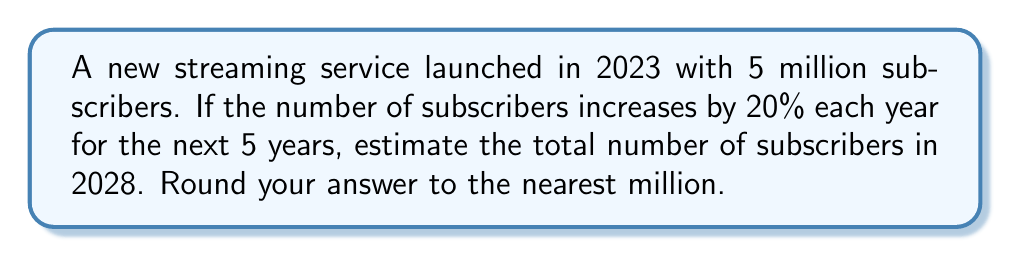What is the answer to this math problem? Let's approach this step-by-step:

1) The initial number of subscribers in 2023 is 5 million.

2) Each year, the number of subscribers increases by 20%. This means we multiply the previous year's number by 1.20 (100% + 20% = 120% = 1.20).

3) Let's calculate the number of subscribers for each year:

   2023 (initial): 5 million
   2024: $5 \times 1.20 = 6$ million
   2025: $6 \times 1.20 = 7.2$ million
   2026: $7.2 \times 1.20 = 8.64$ million
   2027: $8.64 \times 1.20 = 10.368$ million
   2028: $10.368 \times 1.20 = 12.4416$ million

4) Alternatively, we can use the compound growth formula:

   $A = P(1 + r)^n$

   Where:
   $A$ = Final amount
   $P$ = Initial principal balance
   $r$ = Annual interest rate (in decimal form)
   $n$ = Number of years

   Plugging in our values:

   $A = 5,000,000(1 + 0.20)^5 = 5,000,000(1.20)^5 = 12,441,600$

5) Rounding to the nearest million, we get 12 million subscribers in 2028.
Answer: 12 million subscribers 